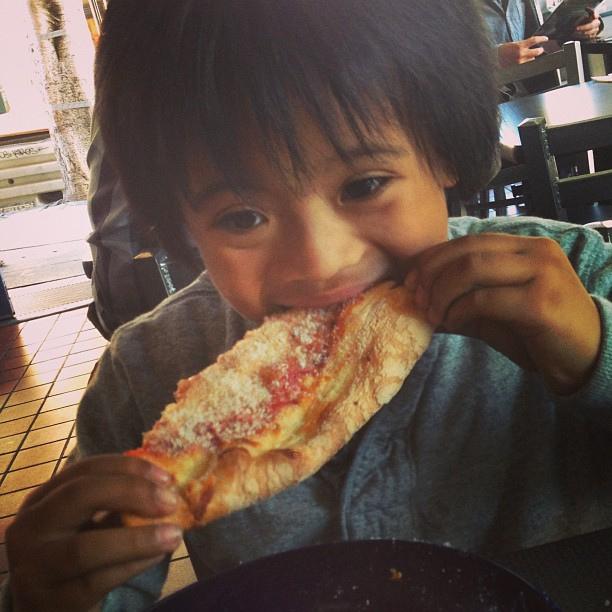What is the child holding in hand?
Give a very brief answer. Pizza. How hungry is this child?
Answer briefly. Very. What color is the child's hair?
Quick response, please. Black. What is the floor made of?
Concise answer only. Tile. Is this child causation?
Keep it brief. No. 